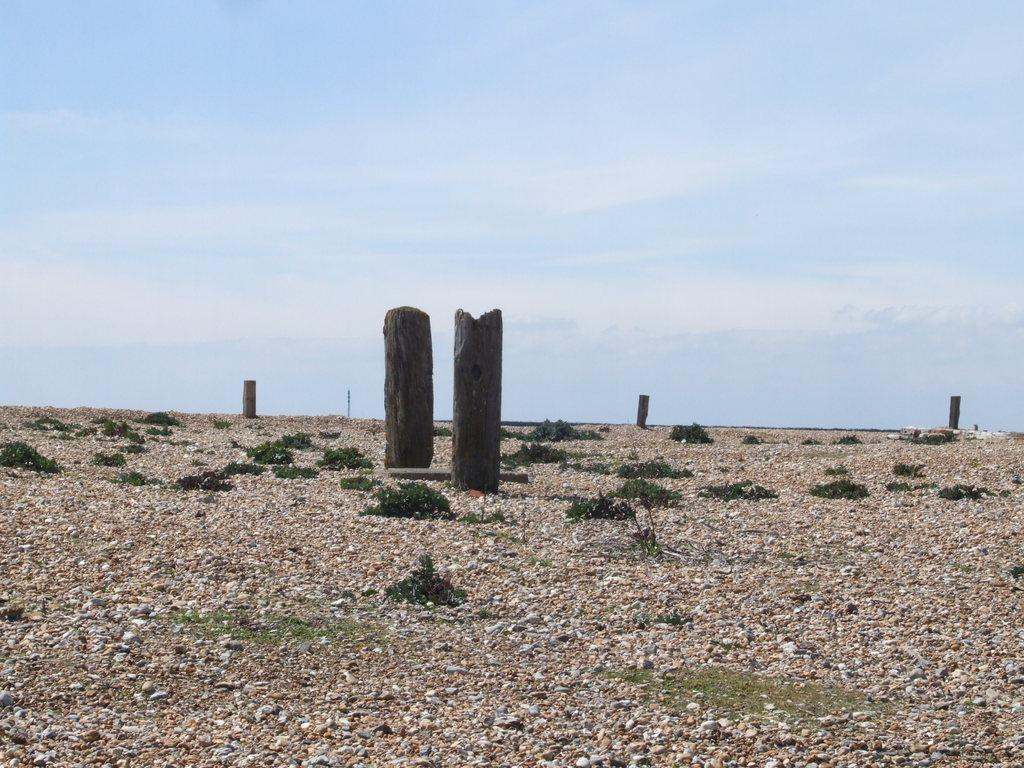What is located in the center of the image? There are logs in the center of the image. What can be found at the bottom of the image? There are stones and shrubs at the bottom of the image. What is visible in the background of the image? The sky is visible in the background of the image. What type of watch can be seen on the shrubs in the image? There is no watch present in the image; it features logs, stones, shrubs, and the sky. What arithmetic problem is being solved by the stones in the image? There is no arithmetic problem being solved by the stones in the image; they are simply located at the bottom of the image. 